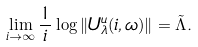<formula> <loc_0><loc_0><loc_500><loc_500>\lim _ { i \to \infty } \frac { 1 } { i } \log \| U _ { \lambda } ^ { u } ( i , \omega ) \| = \tilde { \Lambda } .</formula> 